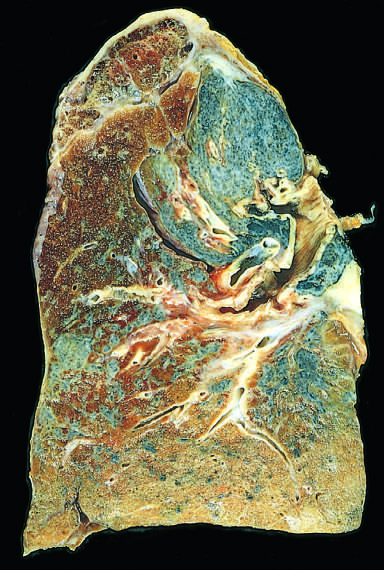has scarring contracted the upper lobe into a small dark mass?
Answer the question using a single word or phrase. Yes 